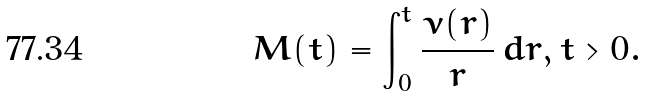Convert formula to latex. <formula><loc_0><loc_0><loc_500><loc_500>M ( t ) = \int _ { 0 } ^ { t } \frac { \nu ( r ) } { r } \, d r , t > 0 .</formula> 